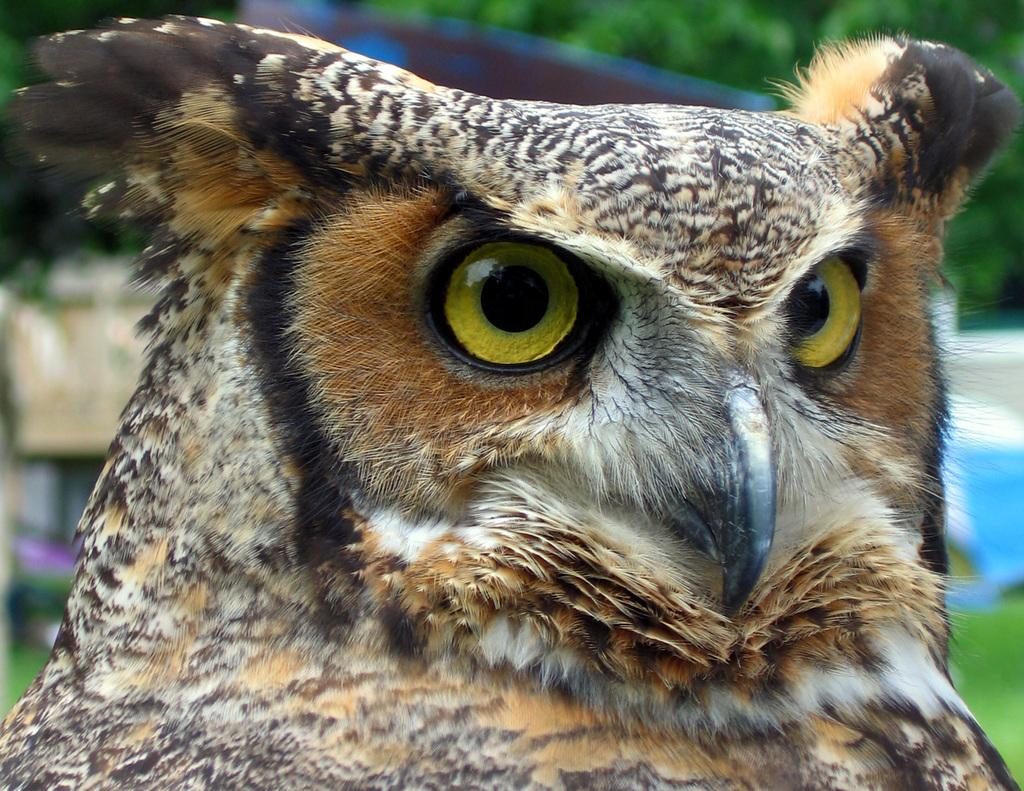What animal is the main subject of the image? There is an owl in the image. Where is the owl located in the image? The owl is at the middle of the image. What can be seen in the background of the image? There are trees in the background of the image. What is the price of the rain in the image? There is no rain present in the image, and therefore no price can be determined. 